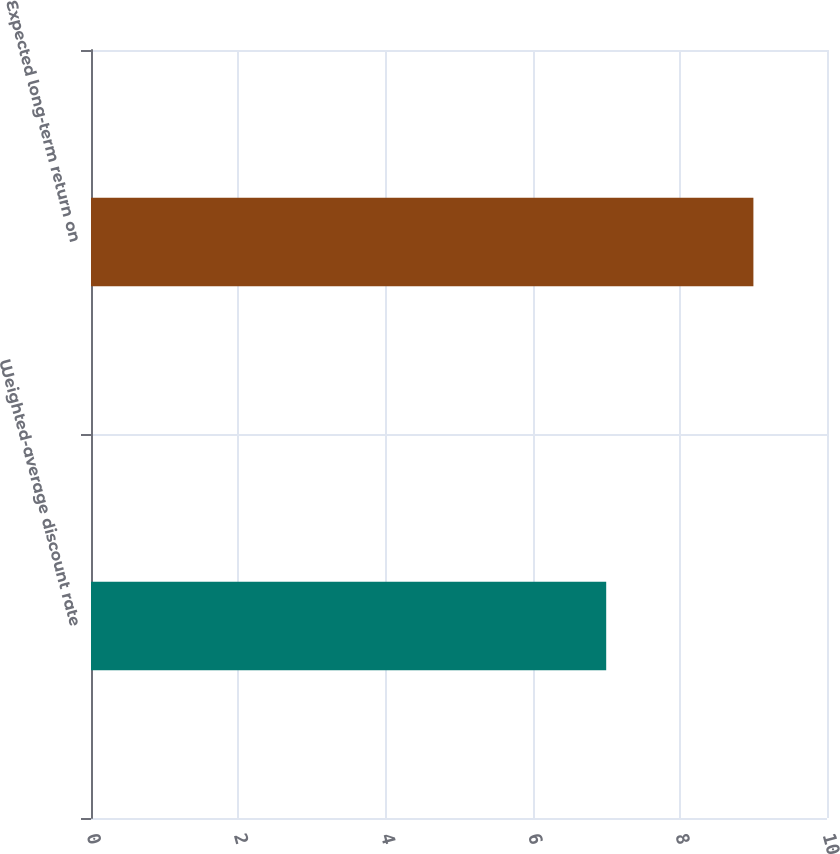Convert chart. <chart><loc_0><loc_0><loc_500><loc_500><bar_chart><fcel>Weighted-average discount rate<fcel>Expected long-term return on<nl><fcel>7<fcel>9<nl></chart> 